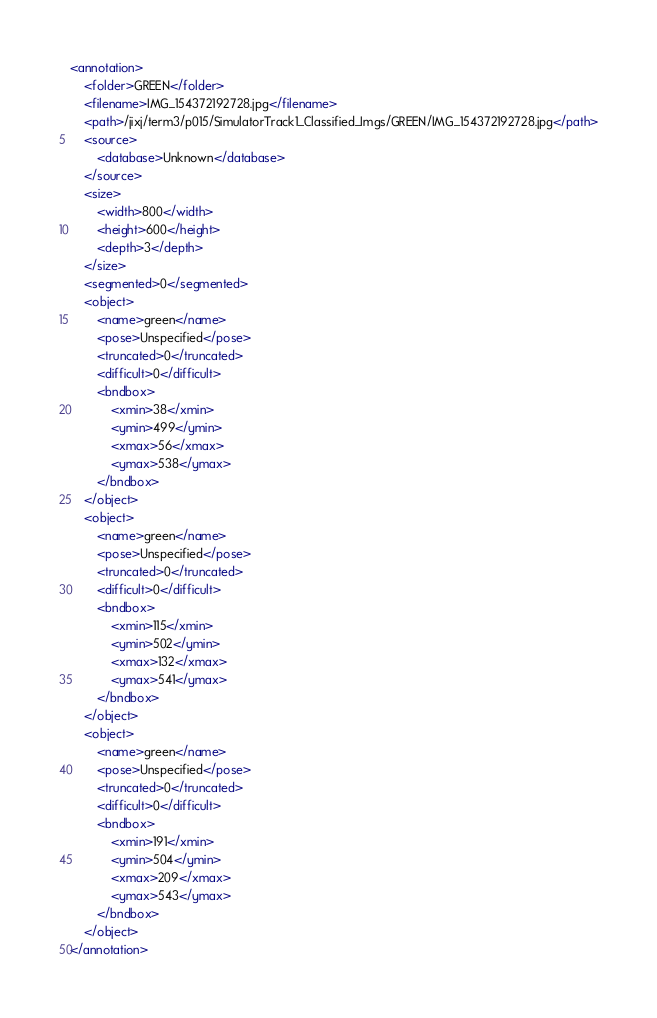<code> <loc_0><loc_0><loc_500><loc_500><_XML_><annotation>
	<folder>GREEN</folder>
	<filename>IMG_154372192728.jpg</filename>
	<path>/jixj/term3/p015/SimulatorTrack1_Classified_Imgs/GREEN/IMG_154372192728.jpg</path>
	<source>
		<database>Unknown</database>
	</source>
	<size>
		<width>800</width>
		<height>600</height>
		<depth>3</depth>
	</size>
	<segmented>0</segmented>
	<object>
		<name>green</name>
		<pose>Unspecified</pose>
		<truncated>0</truncated>
		<difficult>0</difficult>
		<bndbox>
			<xmin>38</xmin>
			<ymin>499</ymin>
			<xmax>56</xmax>
			<ymax>538</ymax>
		</bndbox>
	</object>
	<object>
		<name>green</name>
		<pose>Unspecified</pose>
		<truncated>0</truncated>
		<difficult>0</difficult>
		<bndbox>
			<xmin>115</xmin>
			<ymin>502</ymin>
			<xmax>132</xmax>
			<ymax>541</ymax>
		</bndbox>
	</object>
	<object>
		<name>green</name>
		<pose>Unspecified</pose>
		<truncated>0</truncated>
		<difficult>0</difficult>
		<bndbox>
			<xmin>191</xmin>
			<ymin>504</ymin>
			<xmax>209</xmax>
			<ymax>543</ymax>
		</bndbox>
	</object>
</annotation>
</code> 